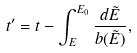<formula> <loc_0><loc_0><loc_500><loc_500>t ^ { \prime } = t - \int _ { E } ^ { E _ { 0 } } \frac { d \tilde { E } } { b ( \tilde { E } ) } ,</formula> 